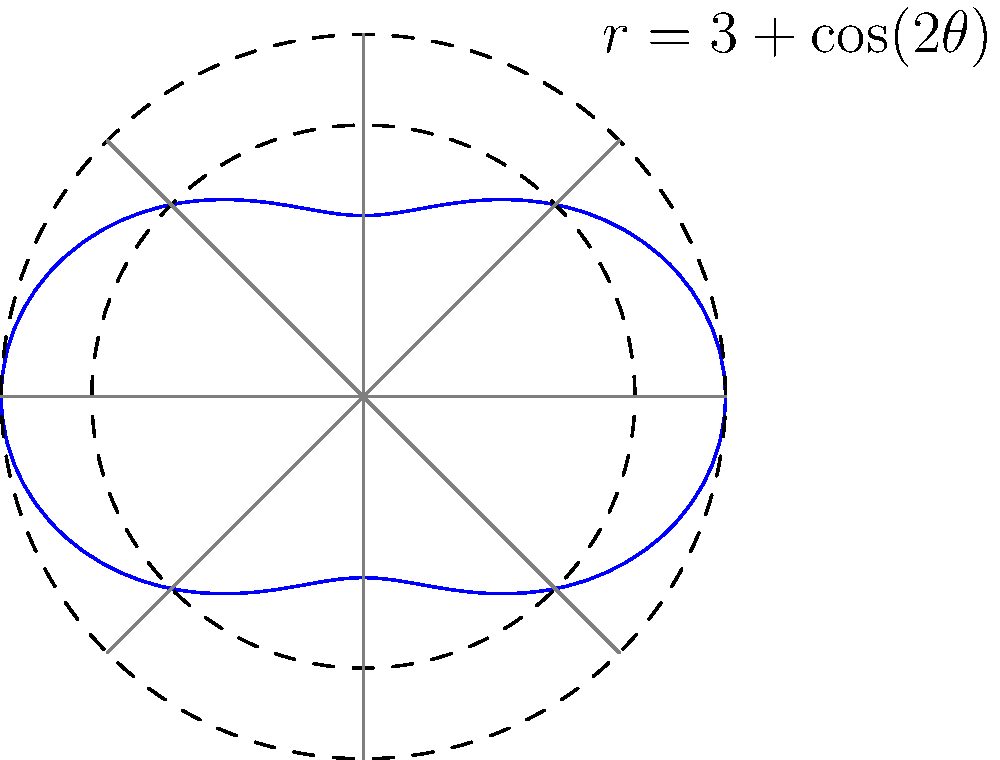As an intelligence officer, you need to calculate the area of an irregularly shaped secure zone. The zone's boundary is represented in polar form by the equation $r = 3 + \cos(2\theta)$, where $r$ is in kilometers. What is the total area of this secure zone in square kilometers? Round your answer to two decimal places. To calculate the area of the region bounded by a polar curve, we use the formula:

$$ A = \frac{1}{2} \int_{0}^{2\pi} r^2(\theta) d\theta $$

For our curve, $r(\theta) = 3 + \cos(2\theta)$. Let's solve this step-by-step:

1) First, we square $r(\theta)$:
   $r^2(\theta) = (3 + \cos(2\theta))^2 = 9 + 6\cos(2\theta) + \cos^2(2\theta)$

2) Now, we set up the integral:
   $$ A = \frac{1}{2} \int_{0}^{2\pi} (9 + 6\cos(2\theta) + \cos^2(2\theta)) d\theta $$

3) Let's integrate each term:
   - $\int_{0}^{2\pi} 9 d\theta = 9\theta |_{0}^{2\pi} = 18\pi$
   - $\int_{0}^{2\pi} 6\cos(2\theta) d\theta = 3\sin(2\theta) |_{0}^{2\pi} = 0$
   - $\int_{0}^{2\pi} \cos^2(2\theta) d\theta = \frac{1}{2}\int_{0}^{2\pi} (1 + \cos(4\theta)) d\theta = \frac{1}{2}(\theta + \frac{1}{4}\sin(4\theta)) |_{0}^{2\pi} = \pi$

4) Adding these results:
   $$ A = \frac{1}{2} (18\pi + 0 + \pi) = \frac{19\pi}{2} $$

5) Calculate the final value and round to two decimal places:
   $$ A = \frac{19\pi}{2} \approx 29.85 \text{ km}^2 $$
Answer: 29.85 km² 